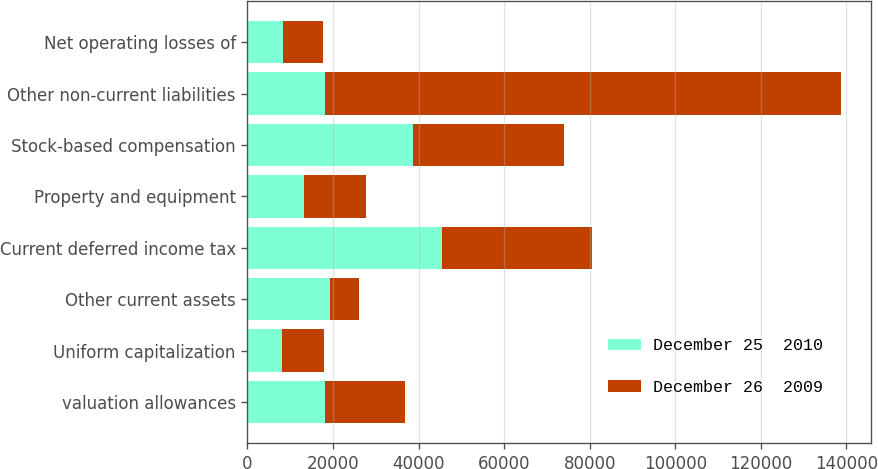Convert chart. <chart><loc_0><loc_0><loc_500><loc_500><stacked_bar_chart><ecel><fcel>valuation allowances<fcel>Uniform capitalization<fcel>Other current assets<fcel>Current deferred income tax<fcel>Property and equipment<fcel>Stock-based compensation<fcel>Other non-current liabilities<fcel>Net operating losses of<nl><fcel>December 25  2010<fcel>18047<fcel>8131<fcel>19244<fcel>45422<fcel>13131<fcel>38663<fcel>18047<fcel>8300<nl><fcel>December 26  2009<fcel>18734<fcel>9690<fcel>6742<fcel>35166<fcel>14658<fcel>35312<fcel>120737<fcel>9411<nl></chart> 